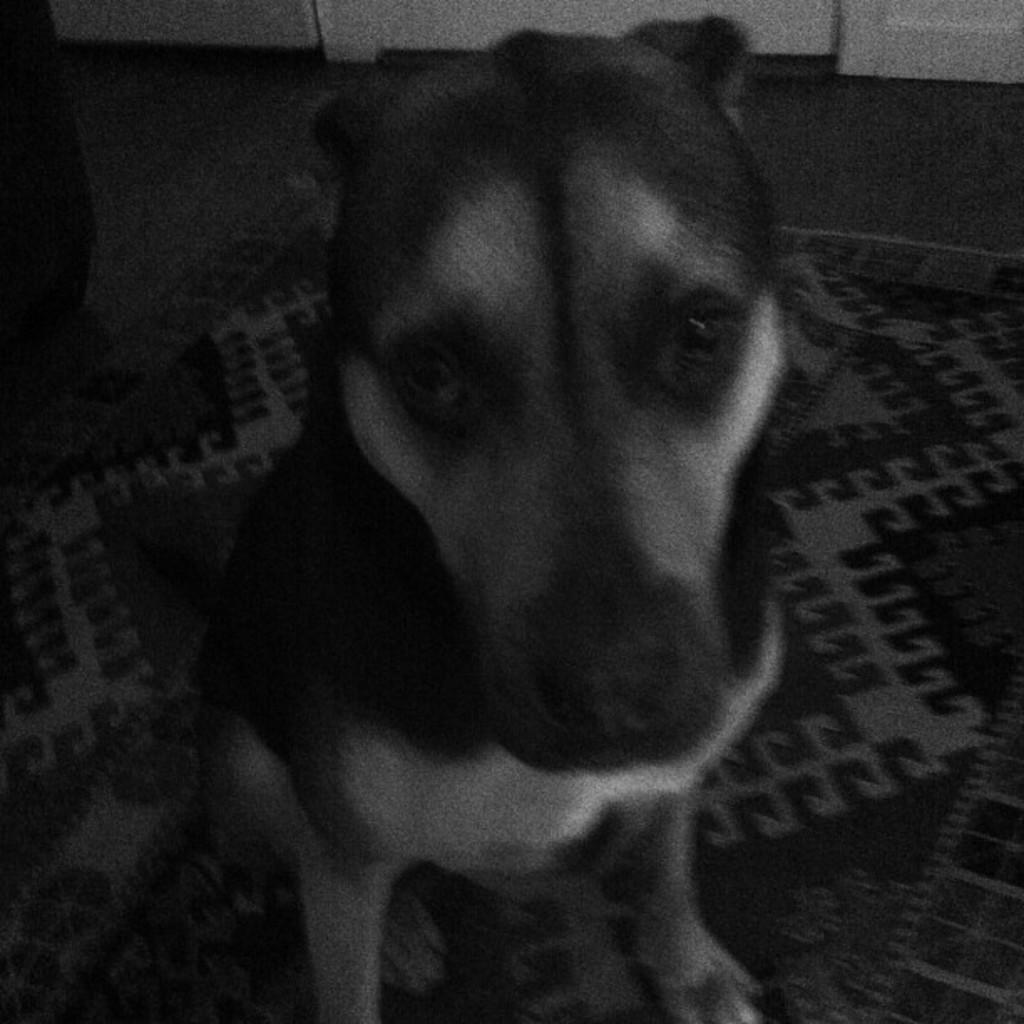What is the color scheme of the image? The image is black and white. What animal can be seen in the image? There is a dog in the image. Where is the dog located in the image? The dog is sitting on a mat. What type of garden can be seen in the background of the image? There is no garden visible in the image, as it is black and white and does not show any background details. 